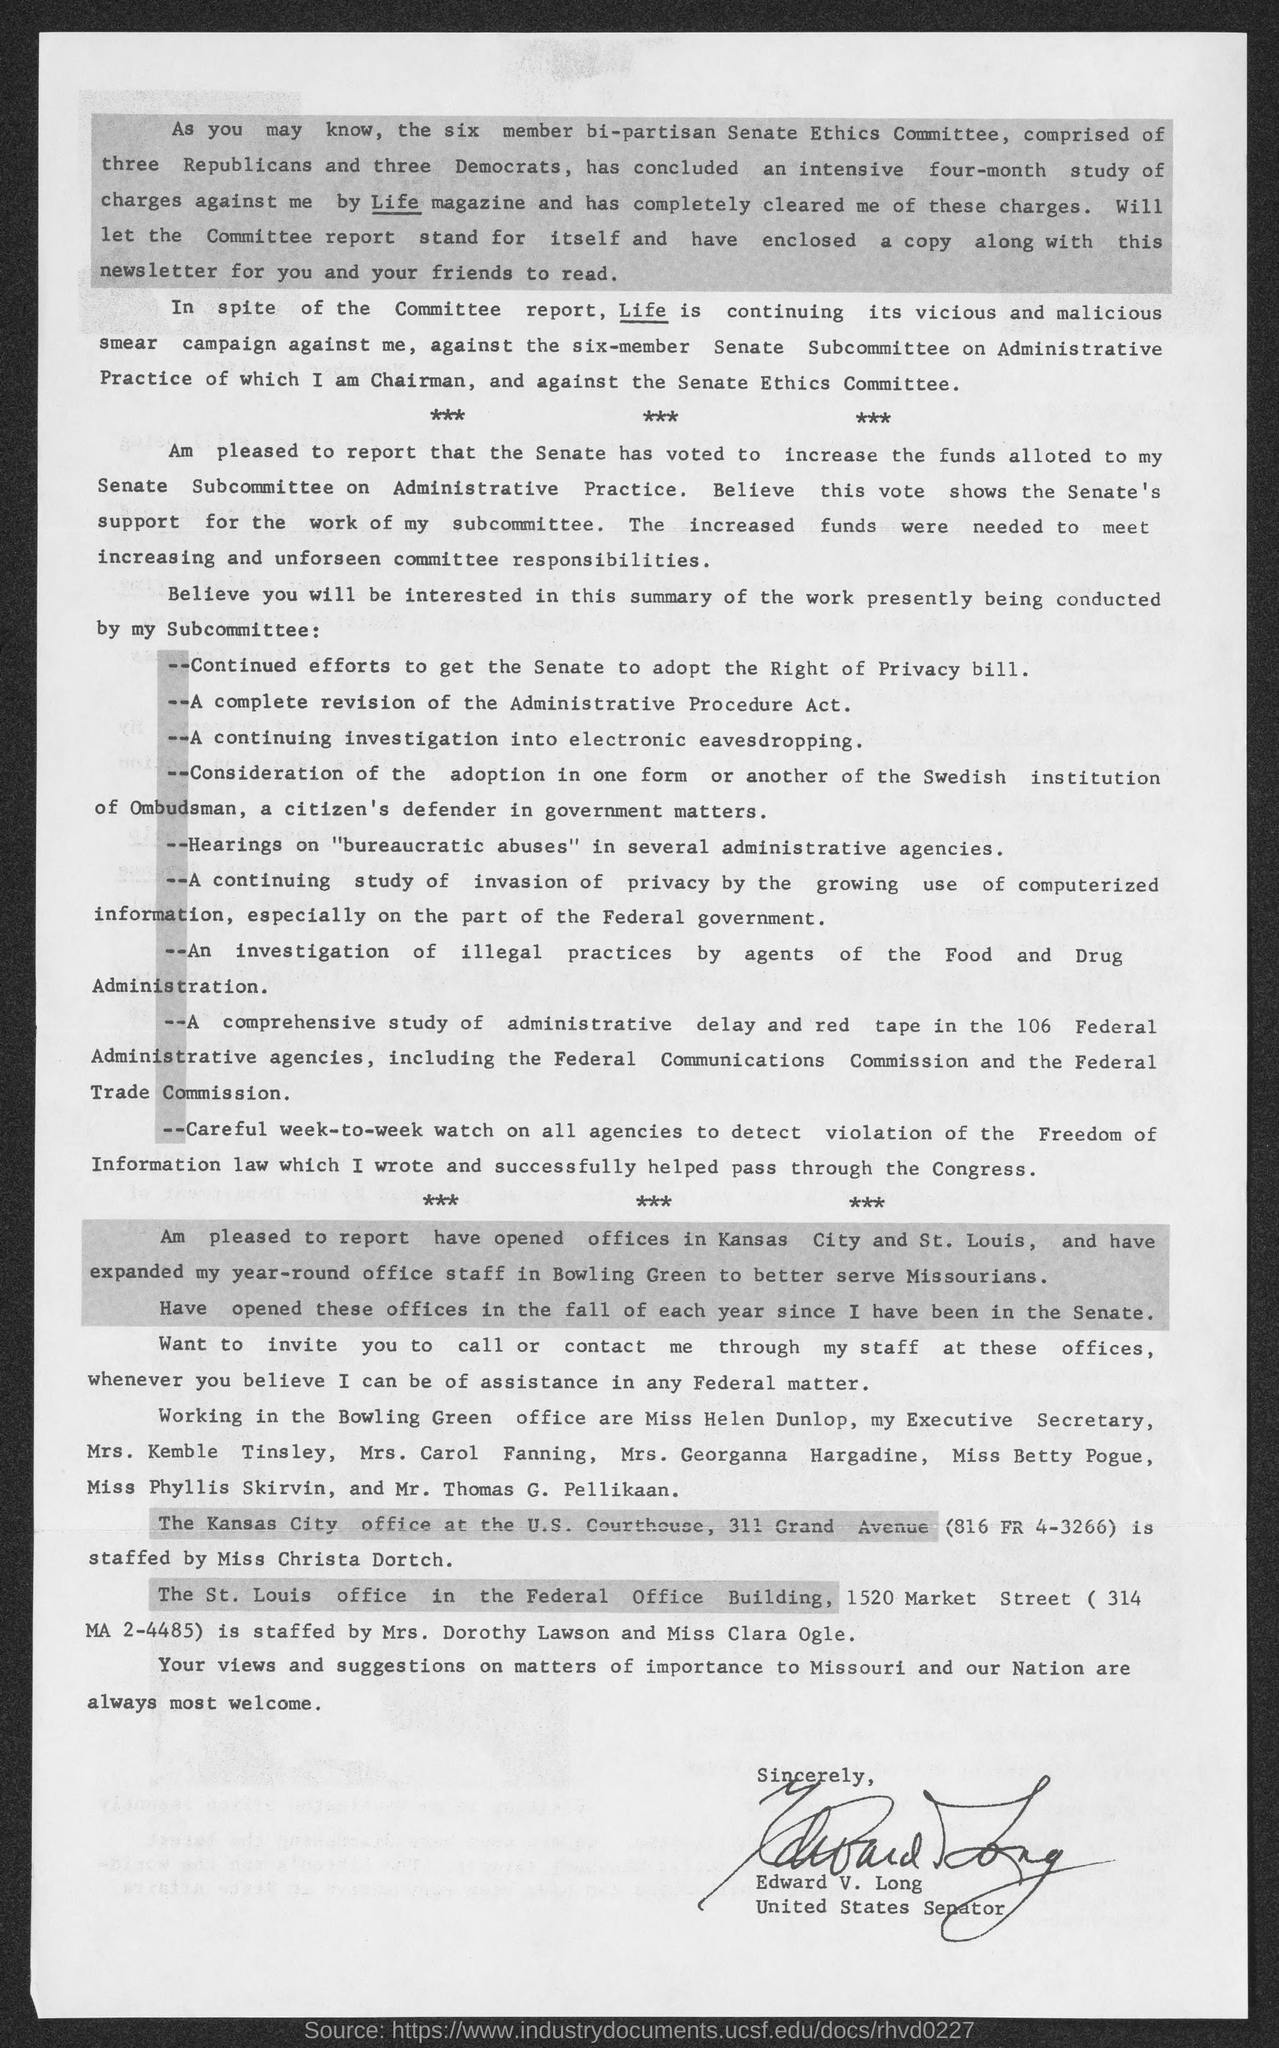Give some essential details in this illustration. Edward V. Long is the current United States Senator. 